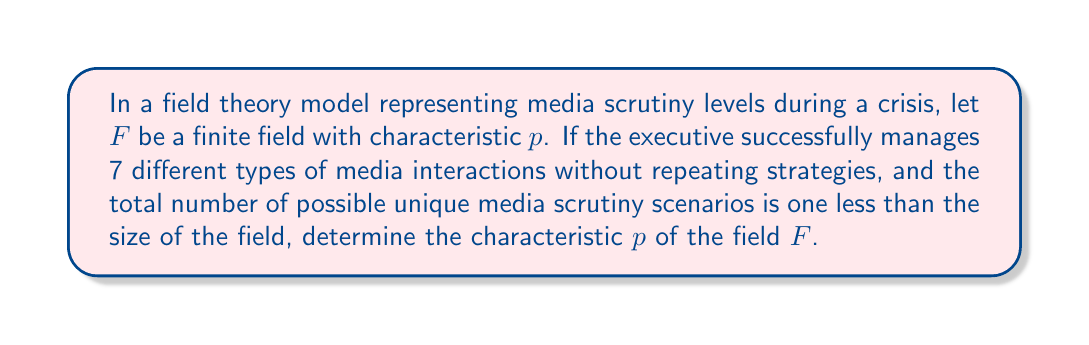What is the answer to this math problem? Let's approach this step-by-step:

1) In a finite field $F$ with characteristic $p$, the number of elements is always a power of $p$, say $p^n$ where $n$ is a positive integer.

2) Given that the executive manages 7 different types of media interactions without repetition, we can infer that the field must have at least 7 elements.

3) The problem states that the total number of possible unique media scrutiny scenarios is one less than the size of the field. Mathematically, this means:

   $|F| - 1 = \text{number of scenarios}$

4) Since $|F| = p^n$, we can write:

   $p^n - 1 = \text{number of scenarios}$

5) The number of scenarios must be divisible by 7 (as there are 7 different types of interactions). So:

   $p^n - 1 = 7k$, where $k$ is some positive integer.

6) The smallest possible value for $p^n$ that satisfies this condition and is greater than 7 is 8.

7) When $p^n = 8$, we have:

   $8 - 1 = 7$

8) Since $8 = 2^3$, we can conclude that $p = 2$ and $n = 3$.

Therefore, the characteristic of the field $F$ is 2.
Answer: $p = 2$ 